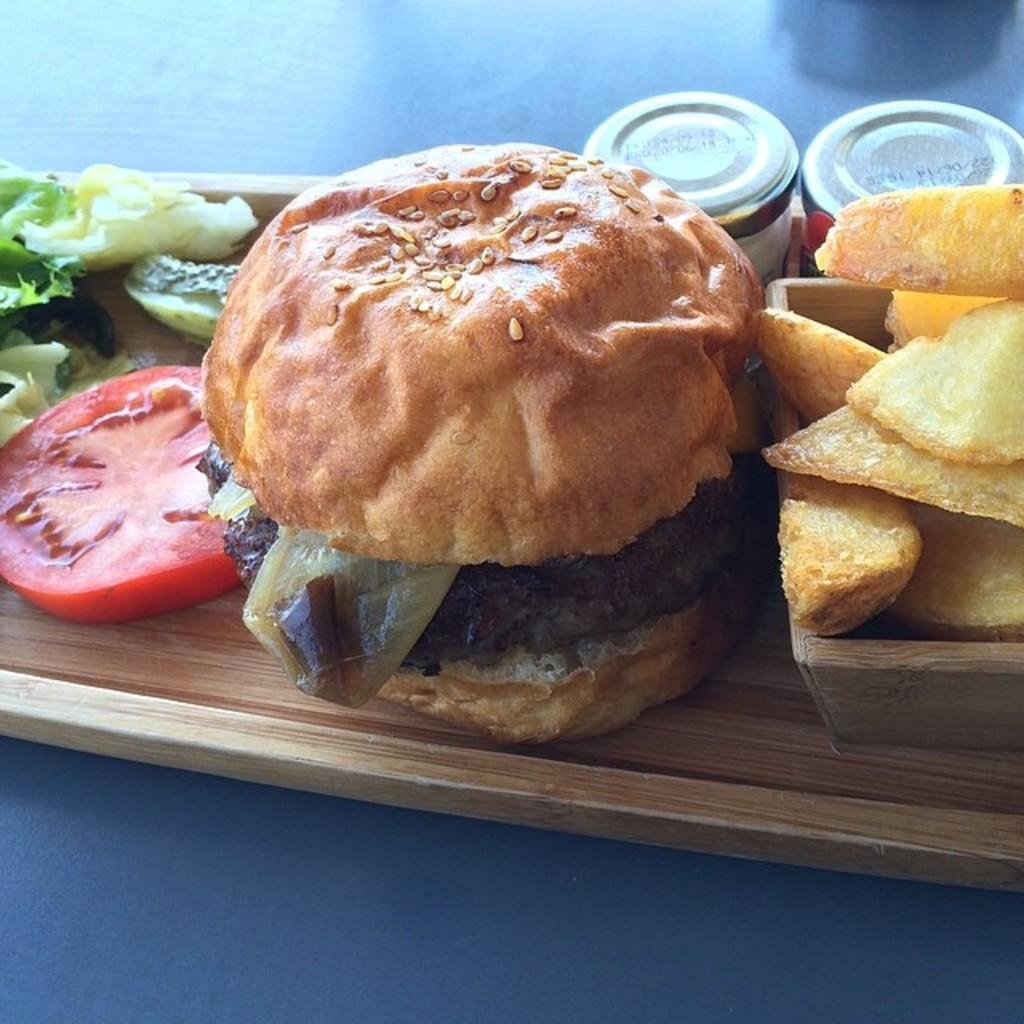What is located at the bottom of the image? There is a table at the bottom of the image. What can be found on the table? There are food items and bottles on the table. How many kittens are playing with the food items on the table? There are no kittens present in the image; it only shows food items and bottles on the table. 